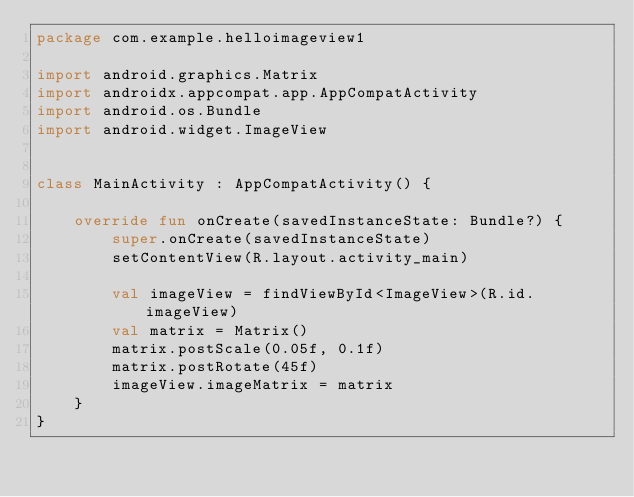<code> <loc_0><loc_0><loc_500><loc_500><_Kotlin_>package com.example.helloimageview1

import android.graphics.Matrix
import androidx.appcompat.app.AppCompatActivity
import android.os.Bundle
import android.widget.ImageView


class MainActivity : AppCompatActivity() {

    override fun onCreate(savedInstanceState: Bundle?) {
        super.onCreate(savedInstanceState)
        setContentView(R.layout.activity_main)

        val imageView = findViewById<ImageView>(R.id.imageView)
        val matrix = Matrix()
        matrix.postScale(0.05f, 0.1f)
        matrix.postRotate(45f)
        imageView.imageMatrix = matrix
    }
}
</code> 